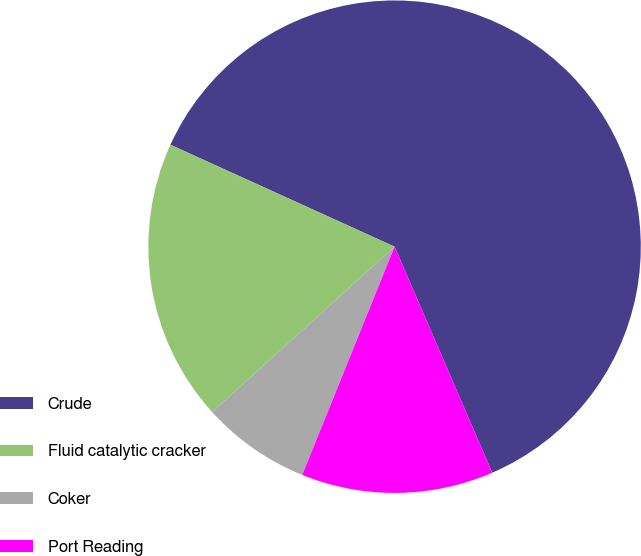Convert chart to OTSL. <chart><loc_0><loc_0><loc_500><loc_500><pie_chart><fcel>Crude<fcel>Fluid catalytic cracker<fcel>Coker<fcel>Port Reading<nl><fcel>61.71%<fcel>18.51%<fcel>7.16%<fcel>12.61%<nl></chart> 